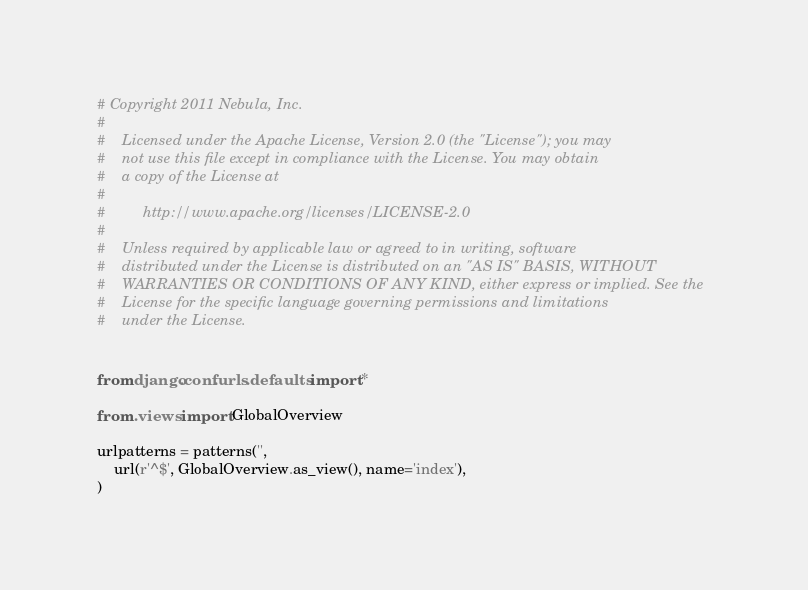<code> <loc_0><loc_0><loc_500><loc_500><_Python_># Copyright 2011 Nebula, Inc.
#
#    Licensed under the Apache License, Version 2.0 (the "License"); you may
#    not use this file except in compliance with the License. You may obtain
#    a copy of the License at
#
#         http://www.apache.org/licenses/LICENSE-2.0
#
#    Unless required by applicable law or agreed to in writing, software
#    distributed under the License is distributed on an "AS IS" BASIS, WITHOUT
#    WARRANTIES OR CONDITIONS OF ANY KIND, either express or implied. See the
#    License for the specific language governing permissions and limitations
#    under the License.


from django.conf.urls.defaults import *

from .views import GlobalOverview

urlpatterns = patterns('',
    url(r'^$', GlobalOverview.as_view(), name='index'),
)
</code> 